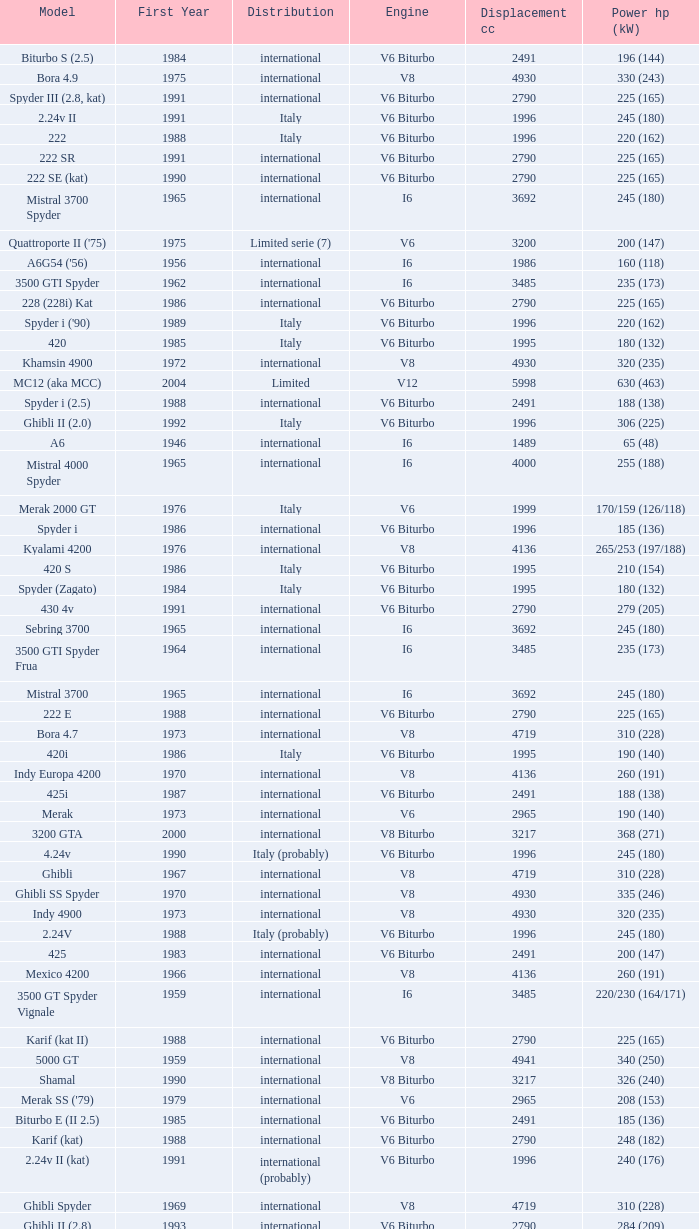Help me parse the entirety of this table. {'header': ['Model', 'First Year', 'Distribution', 'Engine', 'Displacement cc', 'Power hp (kW)'], 'rows': [['Biturbo S (2.5)', '1984', 'international', 'V6 Biturbo', '2491', '196 (144)'], ['Bora 4.9', '1975', 'international', 'V8', '4930', '330 (243)'], ['Spyder III (2.8, kat)', '1991', 'international', 'V6 Biturbo', '2790', '225 (165)'], ['2.24v II', '1991', 'Italy', 'V6 Biturbo', '1996', '245 (180)'], ['222', '1988', 'Italy', 'V6 Biturbo', '1996', '220 (162)'], ['222 SR', '1991', 'international', 'V6 Biturbo', '2790', '225 (165)'], ['222 SE (kat)', '1990', 'international', 'V6 Biturbo', '2790', '225 (165)'], ['Mistral 3700 Spyder', '1965', 'international', 'I6', '3692', '245 (180)'], ["Quattroporte II ('75)", '1975', 'Limited serie (7)', 'V6', '3200', '200 (147)'], ["A6G54 ('56)", '1956', 'international', 'I6', '1986', '160 (118)'], ['3500 GTI Spyder', '1962', 'international', 'I6', '3485', '235 (173)'], ['228 (228i) Kat', '1986', 'international', 'V6 Biturbo', '2790', '225 (165)'], ["Spyder i ('90)", '1989', 'Italy', 'V6 Biturbo', '1996', '220 (162)'], ['420', '1985', 'Italy', 'V6 Biturbo', '1995', '180 (132)'], ['Khamsin 4900', '1972', 'international', 'V8', '4930', '320 (235)'], ['MC12 (aka MCC)', '2004', 'Limited', 'V12', '5998', '630 (463)'], ['Spyder i (2.5)', '1988', 'international', 'V6 Biturbo', '2491', '188 (138)'], ['Ghibli II (2.0)', '1992', 'Italy', 'V6 Biturbo', '1996', '306 (225)'], ['A6', '1946', 'international', 'I6', '1489', '65 (48)'], ['Mistral 4000 Spyder', '1965', 'international', 'I6', '4000', '255 (188)'], ['Merak 2000 GT', '1976', 'Italy', 'V6', '1999', '170/159 (126/118)'], ['Spyder i', '1986', 'international', 'V6 Biturbo', '1996', '185 (136)'], ['Kyalami 4200', '1976', 'international', 'V8', '4136', '265/253 (197/188)'], ['420 S', '1986', 'Italy', 'V6 Biturbo', '1995', '210 (154)'], ['Spyder (Zagato)', '1984', 'Italy', 'V6 Biturbo', '1995', '180 (132)'], ['430 4v', '1991', 'international', 'V6 Biturbo', '2790', '279 (205)'], ['Sebring 3700', '1965', 'international', 'I6', '3692', '245 (180)'], ['3500 GTI Spyder Frua', '1964', 'international', 'I6', '3485', '235 (173)'], ['Mistral 3700', '1965', 'international', 'I6', '3692', '245 (180)'], ['222 E', '1988', 'international', 'V6 Biturbo', '2790', '225 (165)'], ['Bora 4.7', '1973', 'international', 'V8', '4719', '310 (228)'], ['420i', '1986', 'Italy', 'V6 Biturbo', '1995', '190 (140)'], ['Indy Europa 4200', '1970', 'international', 'V8', '4136', '260 (191)'], ['425i', '1987', 'international', 'V6 Biturbo', '2491', '188 (138)'], ['Merak', '1973', 'international', 'V6', '2965', '190 (140)'], ['3200 GTA', '2000', 'international', 'V8 Biturbo', '3217', '368 (271)'], ['4.24v', '1990', 'Italy (probably)', 'V6 Biturbo', '1996', '245 (180)'], ['Ghibli', '1967', 'international', 'V8', '4719', '310 (228)'], ['Ghibli SS Spyder', '1970', 'international', 'V8', '4930', '335 (246)'], ['Indy 4900', '1973', 'international', 'V8', '4930', '320 (235)'], ['2.24V', '1988', 'Italy (probably)', 'V6 Biturbo', '1996', '245 (180)'], ['425', '1983', 'international', 'V6 Biturbo', '2491', '200 (147)'], ['Mexico 4200', '1966', 'international', 'V8', '4136', '260 (191)'], ['3500 GT Spyder Vignale', '1959', 'international', 'I6', '3485', '220/230 (164/171)'], ['Karif (kat II)', '1988', 'international', 'V6 Biturbo', '2790', '225 (165)'], ['5000 GT', '1959', 'international', 'V8', '4941', '340 (250)'], ['Shamal', '1990', 'international', 'V8 Biturbo', '3217', '326 (240)'], ["Merak SS ('79)", '1979', 'international', 'V6', '2965', '208 (153)'], ['Biturbo E (II 2.5)', '1985', 'international', 'V6 Biturbo', '2491', '185 (136)'], ['Karif (kat)', '1988', 'international', 'V6 Biturbo', '2790', '248 (182)'], ['2.24v II (kat)', '1991', 'international (probably)', 'V6 Biturbo', '1996', '240 (176)'], ['Ghibli Spyder', '1969', 'international', 'V8', '4719', '310 (228)'], ['Ghibli II (2.8)', '1993', 'international', 'V6 Biturbo', '2790', '284 (209)'], ["Quattroporte ('66)", '1966', 'international', 'V8', '4719', '290 (213)'], ['Merak SS', '1975', 'international', 'V6', '2965', '220 (162)'], ['Spyder III (kat)', '1991', 'Italy', 'V6 Biturbo', '1996', '240 (176)'], ["Quattroporte III ('81)", '1981', 'international', 'V8', '4930', '282 (207)'], ["Khamsin ('79)", '1979', 'international', 'V8', '4930', '280 (206)'], ['Quattroporte (2.0)', '1994', 'Italy', 'V6 Biturbo', '1996', '287 (211)'], ['Mexico 4700', '1969', 'international', 'V8', '4719', '310 (228)'], ['Bora 4.9 (US)', '1974', 'USA only', 'V8', '4930', '300 (221)'], ['GranTurismo', '2008', 'international', 'V8', '4244', '405'], ['Spyder GT', '2001', 'international', 'V8', '4244', '390 (287)'], ['Spyder i (2.8)', '1989', 'international', 'V6 Biturbo', '2790', '250 (184)'], ['Spyder III', '1991', 'Italy', 'V6 Biturbo', '1996', '245 (180)'], ['Ghibli SS', '1970', 'international', 'V8', '4930', '335 (246)'], ['Karif', '1988', 'international', 'V6 Biturbo', '2790', '285 (210)'], ['Mistral 4000', '1965', 'international', 'I6', '4000', '255 (188)'], ["5000 GT ('61)", '1961', 'international', 'V8', '4941', '330 (243)'], ['422', '1988', 'Italy', 'V6 Biturbo', '1996', '220 (162)'], ['430', '1987', 'international', 'V6 Biturbo', '2790', '225 (165)'], ['GranCabrio', '2010', 'international', 'V8', '4691', '433'], ['3500 GTI', '1962', 'international', 'I6', '3485', '235 (173)'], ['Quattroporte (2.8)', '1994', 'international', 'V6 Biturbo', '2790', '284 (209)'], ['Quattroporte V', '2004', 'international', 'V8', '4244', '400 (294)'], ['Quattroporte V6 Evoluzione', '1998', 'international', 'V6 Biturbo', '2790', '284 (209)'], ['Kyalami 4900', '1978', 'international', 'V8', '4930', '280 (206)'], ["Spyder i ('87)", '1987', 'international', 'V6 Biturbo', '1996', '195 (143)'], ['Biturbo S (II)', '1985', 'Italy', 'V6 Biturbo', '1995', '210 (154)'], ['Biturbo Si', '1987', 'Italy', 'V6 Biturbo', '1995', '220 (162)'], ['Ghibli Primatist', '1996', 'international', 'V6 Biturbo', '1996', '306 (225)'], ['4porte (Quattroporte III)', '1976', 'international', 'V8', '4136', '255 (188)'], ['Ghibli Cup', '1995', 'international', 'V6 Biturbo', '1996', '330 (243)'], ['4.24v II (kat)', '1991', 'Italy (probably)', 'V6 Biturbo', '1996', '240 (176)'], ['Biturbo E', '1983', 'international', 'V6 Biturbo', '2491', '185 (136)'], ['Quattroporte Royale (III)', '1986', 'international', 'V8', '4930', '300 (221)'], ['A6G', '1951', 'international', 'I6', '1954', '100 (74)'], ['228 (228i)', '1986', 'international', 'V6 Biturbo', '2790', '250 (184)'], ['Biturbo Si (2.5)', '1987', 'international', 'V6 Biturbo', '2491', '188 (138)'], ['Indy Europa 4700', '1971', 'international', 'V8', '4719', '290 (213)'], ['Coupé GT', '2001', 'international', 'V8', '4244', '390 (287)'], ['Barchetta Stradale', '1992', 'Prototype', 'V6 Biturbo', '1996', '306 (225)'], ['222 SE', '1990', 'international', 'V6 Biturbo', '2790', '250 (184)'], ['Biturbo i', '1986', 'Italy', 'V6 Biturbo', '1995', '185 (136)'], ['Racing', '1991', 'Italy', 'V6 Biturbo', '1996', '283 (208)'], ['Mistral 3500', '1963', 'international', 'I6', '3485', '235 (173)'], ['Quattroporte Ottocilindri', '1995', 'international', 'V8 Biturbo', '3217', '335 (246)'], ['222 4v', '1988', 'international', 'V6 Biturbo', '2790', '279 (205)'], ['4.18v', '1990', 'Italy', 'V6 Biturbo', '1995', '220 (162)'], ['Khamsin 4700', '1972', 'international', 'V8', '4719', '290 (213)'], ['Spyder i (2.8, kat)', '1989', 'international', 'V6 Biturbo', '2790', '225 (165)'], ['Quattroporte', '1963', 'international', 'V8', '4136', '260 (191)'], ['3200 GT', '1998', 'international', 'V8 Biturbo', '3217', '370 (272)'], ['3500 GT Touring', '1957', 'international', 'I6', '3485', '220/230 (164/171)'], ['Barchetta Stradale 2.8', '1992', 'Single, Conversion', 'V6 Biturbo', '2790', '284 (209)'], ['Spyder CC', '2001', 'international', 'V8', '4244', '390 (287)'], ['Gran Sport', '2002', 'international', 'V8', '4244', '400 (294)'], ['Sebring 4000', '1965', 'international', 'I6', '4000', '255 (188)'], ['Biturbo S', '1983', 'Italy', 'V6 Biturbo', '1995', '205 (151)'], ['Quattroporte II', '1974', 'pre-production (6)', 'V6', '2965', '190 (140)'], ['A6G54', '1954', 'international', 'I6', '1986', '150 (110)'], ['Biturbo', '1981', 'Italy', 'V6 Biturbo', '1995', '180 (132)'], ['Quattroporte V8 Evoluzione', '1998', 'international', 'V8 Biturbo', '3217', '335 (246)'], ['Coupé CC', '2001', 'international', 'V8', '4244', '390 (287)'], ['Biturbo (II)', '1985', 'Italy', 'V6 Biturbo', '1995', '180 (132)'], ['Spyder (2.5)', '1984', 'international', 'V6 Biturbo', '2491', '192 (141)']]} What is the lowest First Year, when Model is "Quattroporte (2.8)"? 1994.0. 